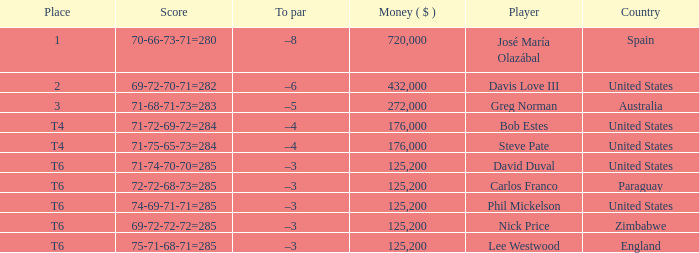Which Place has a To par of –8? 1.0. 